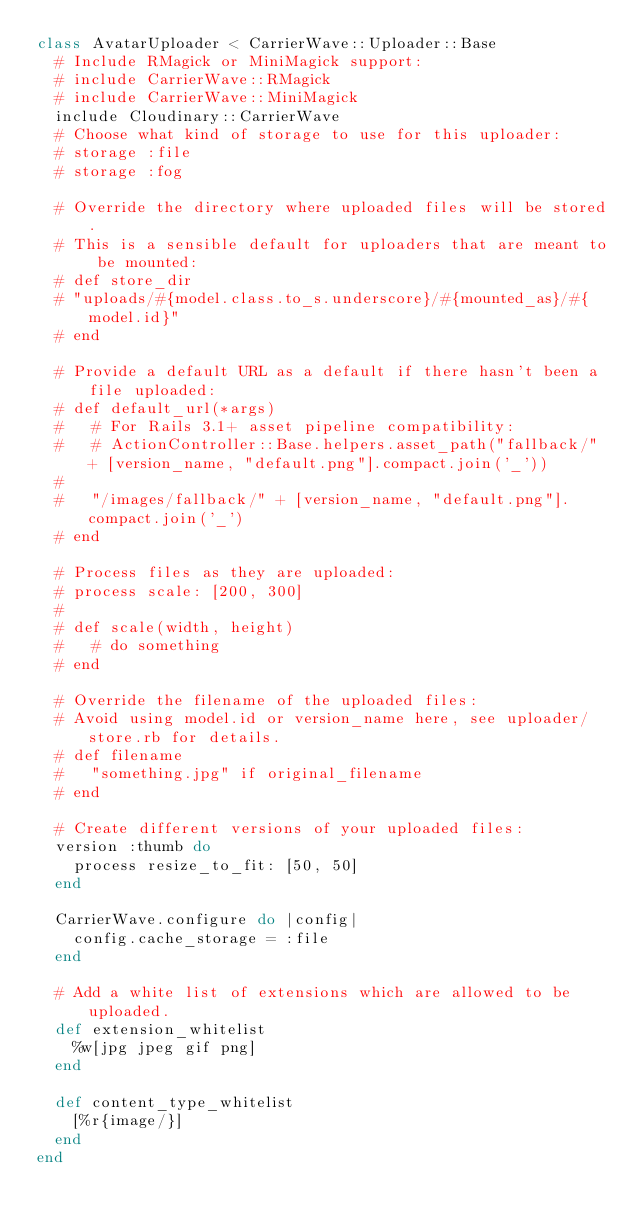Convert code to text. <code><loc_0><loc_0><loc_500><loc_500><_Ruby_>class AvatarUploader < CarrierWave::Uploader::Base
  # Include RMagick or MiniMagick support:
  # include CarrierWave::RMagick
  # include CarrierWave::MiniMagick
  include Cloudinary::CarrierWave
  # Choose what kind of storage to use for this uploader:
  # storage :file
  # storage :fog

  # Override the directory where uploaded files will be stored.
  # This is a sensible default for uploaders that are meant to be mounted:
  # def store_dir
  # "uploads/#{model.class.to_s.underscore}/#{mounted_as}/#{model.id}"
  # end

  # Provide a default URL as a default if there hasn't been a file uploaded:
  # def default_url(*args)
  #   # For Rails 3.1+ asset pipeline compatibility:
  #   # ActionController::Base.helpers.asset_path("fallback/" + [version_name, "default.png"].compact.join('_'))
  #
  #   "/images/fallback/" + [version_name, "default.png"].compact.join('_')
  # end

  # Process files as they are uploaded:
  # process scale: [200, 300]
  #
  # def scale(width, height)
  #   # do something
  # end

  # Override the filename of the uploaded files:
  # Avoid using model.id or version_name here, see uploader/store.rb for details.
  # def filename
  #   "something.jpg" if original_filename
  # end

  # Create different versions of your uploaded files:
  version :thumb do
    process resize_to_fit: [50, 50]
  end

  CarrierWave.configure do |config|
    config.cache_storage = :file
  end

  # Add a white list of extensions which are allowed to be uploaded.
  def extension_whitelist
    %w[jpg jpeg gif png]
  end

  def content_type_whitelist
    [%r{image/}]
  end
end
</code> 